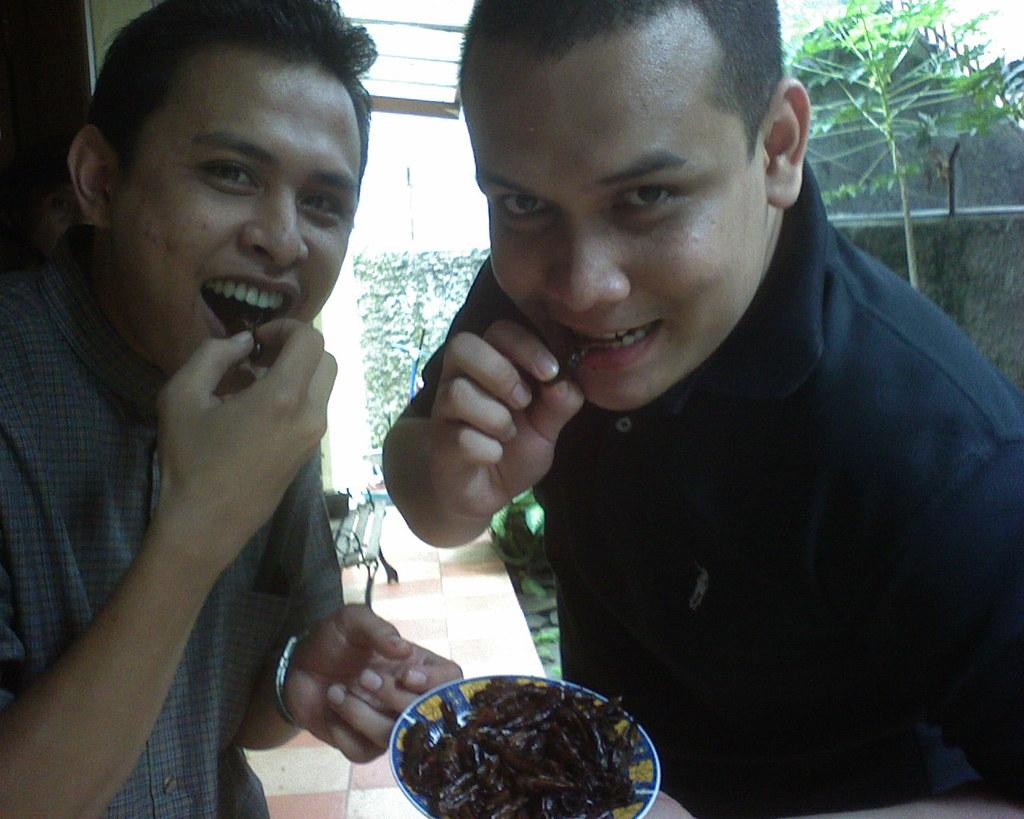How many people are in the image? There are two persons in the image. What are the persons doing in the image? The persons are eating. What is one person holding in the image? One person is holding a bowl with food. What type of vegetation can be seen in the image? There are plants in the image. What type of structure is visible in the image? There is a wall in the image. What type of seating is present in the image? There is a bench in the image. What type of large plant is visible in the image? There is a tree in the image. What type of leather is visible on the tree in the image? There is no leather present on the tree in the image; it is a natural plant. 